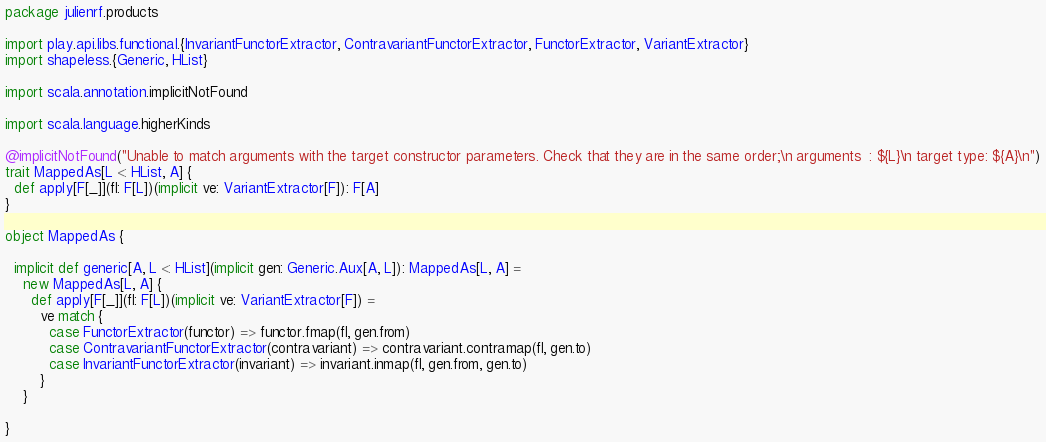<code> <loc_0><loc_0><loc_500><loc_500><_Scala_>package julienrf.products

import play.api.libs.functional.{InvariantFunctorExtractor, ContravariantFunctorExtractor, FunctorExtractor, VariantExtractor}
import shapeless.{Generic, HList}

import scala.annotation.implicitNotFound

import scala.language.higherKinds

@implicitNotFound("Unable to match arguments with the target constructor parameters. Check that they are in the same order;\n arguments  : ${L}\n target type: ${A}\n")
trait MappedAs[L <: HList, A] {
  def apply[F[_]](fl: F[L])(implicit ve: VariantExtractor[F]): F[A]
}

object MappedAs {

  implicit def generic[A, L <: HList](implicit gen: Generic.Aux[A, L]): MappedAs[L, A] =
    new MappedAs[L, A] {
      def apply[F[_]](fl: F[L])(implicit ve: VariantExtractor[F]) =
        ve match {
          case FunctorExtractor(functor) => functor.fmap(fl, gen.from)
          case ContravariantFunctorExtractor(contravariant) => contravariant.contramap(fl, gen.to)
          case InvariantFunctorExtractor(invariant) => invariant.inmap(fl, gen.from, gen.to)
        }
    }

}</code> 